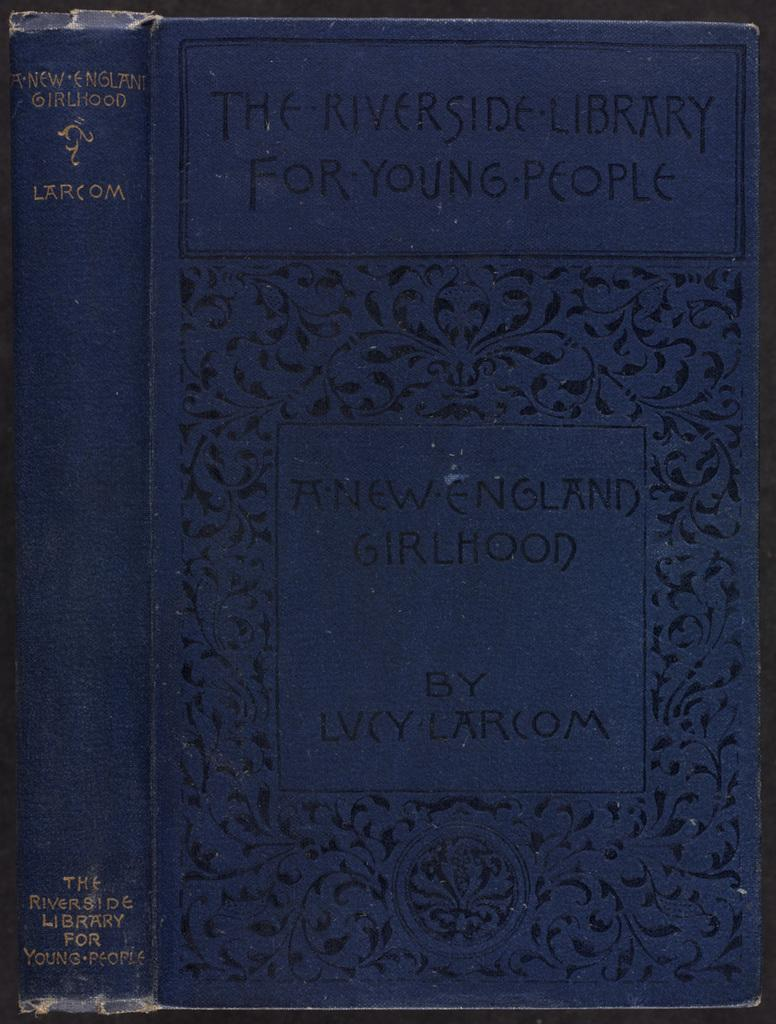<image>
Write a terse but informative summary of the picture. A book from the Riverside Library for Young People. 